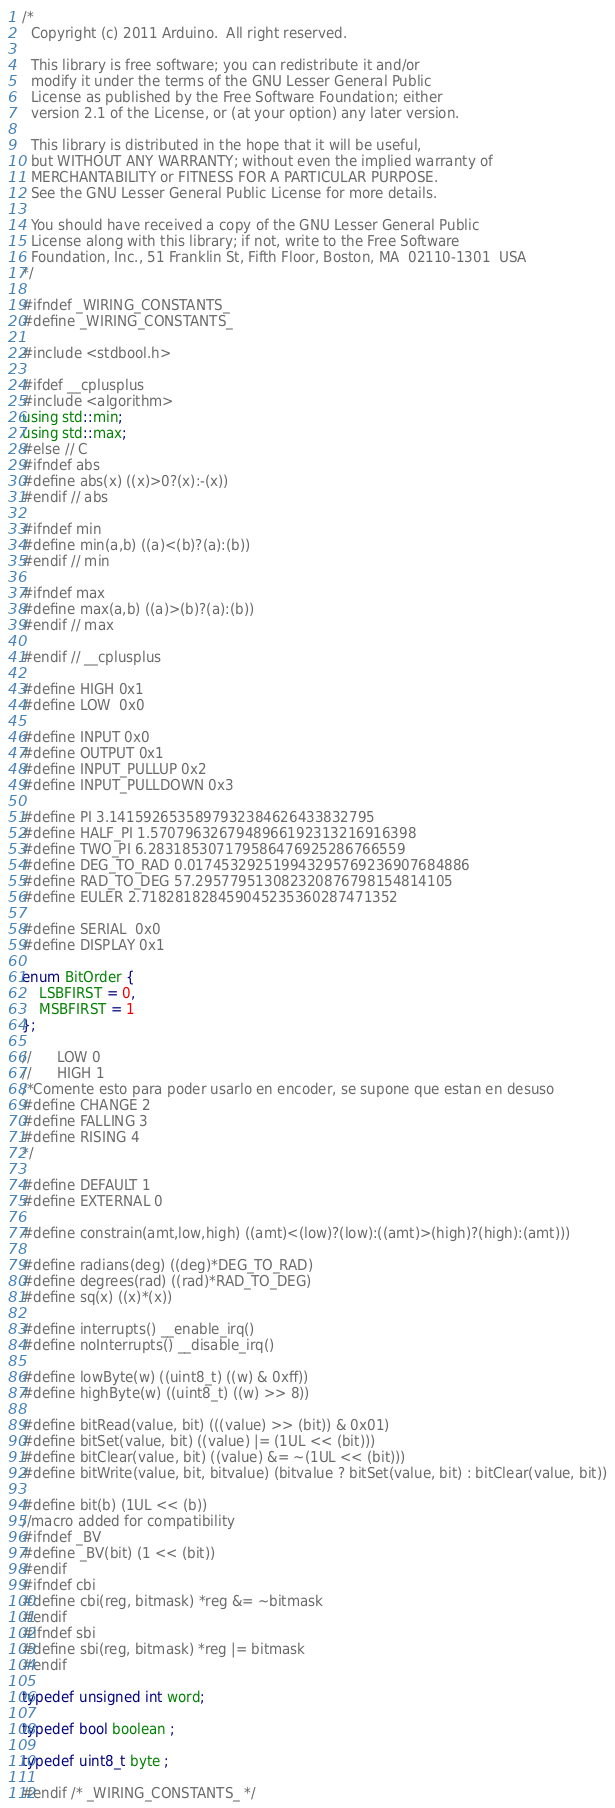<code> <loc_0><loc_0><loc_500><loc_500><_C_>/*
  Copyright (c) 2011 Arduino.  All right reserved.

  This library is free software; you can redistribute it and/or
  modify it under the terms of the GNU Lesser General Public
  License as published by the Free Software Foundation; either
  version 2.1 of the License, or (at your option) any later version.

  This library is distributed in the hope that it will be useful,
  but WITHOUT ANY WARRANTY; without even the implied warranty of
  MERCHANTABILITY or FITNESS FOR A PARTICULAR PURPOSE.
  See the GNU Lesser General Public License for more details.

  You should have received a copy of the GNU Lesser General Public
  License along with this library; if not, write to the Free Software
  Foundation, Inc., 51 Franklin St, Fifth Floor, Boston, MA  02110-1301  USA
*/

#ifndef _WIRING_CONSTANTS_
#define _WIRING_CONSTANTS_

#include <stdbool.h>

#ifdef __cplusplus
#include <algorithm>
using std::min;
using std::max;
#else // C
#ifndef abs
#define abs(x) ((x)>0?(x):-(x))
#endif // abs

#ifndef min
#define min(a,b) ((a)<(b)?(a):(b))
#endif // min

#ifndef max
#define max(a,b) ((a)>(b)?(a):(b))
#endif // max

#endif // __cplusplus

#define HIGH 0x1
#define LOW  0x0

#define INPUT 0x0
#define OUTPUT 0x1
#define INPUT_PULLUP 0x2
#define INPUT_PULLDOWN 0x3

#define PI 3.1415926535897932384626433832795
#define HALF_PI 1.5707963267948966192313216916398
#define TWO_PI 6.283185307179586476925286766559
#define DEG_TO_RAD 0.017453292519943295769236907684886
#define RAD_TO_DEG 57.295779513082320876798154814105
#define EULER 2.718281828459045235360287471352

#define SERIAL  0x0
#define DISPLAY 0x1

enum BitOrder {
	LSBFIRST = 0,
	MSBFIRST = 1
};

//      LOW 0
//      HIGH 1
/*Comente esto para poder usarlo en encoder, se supone que estan en desuso
#define CHANGE 2
#define FALLING 3
#define RISING 4
*/

#define DEFAULT 1
#define EXTERNAL 0

#define constrain(amt,low,high) ((amt)<(low)?(low):((amt)>(high)?(high):(amt)))

#define radians(deg) ((deg)*DEG_TO_RAD)
#define degrees(rad) ((rad)*RAD_TO_DEG)
#define sq(x) ((x)*(x))

#define interrupts() __enable_irq()
#define noInterrupts() __disable_irq()

#define lowByte(w) ((uint8_t) ((w) & 0xff))
#define highByte(w) ((uint8_t) ((w) >> 8))

#define bitRead(value, bit) (((value) >> (bit)) & 0x01)
#define bitSet(value, bit) ((value) |= (1UL << (bit)))
#define bitClear(value, bit) ((value) &= ~(1UL << (bit)))
#define bitWrite(value, bit, bitvalue) (bitvalue ? bitSet(value, bit) : bitClear(value, bit))

#define bit(b) (1UL << (b))
//macro added for compatibility
#ifndef _BV
#define _BV(bit) (1 << (bit))
#endif
#ifndef cbi
#define cbi(reg, bitmask) *reg &= ~bitmask
#endif
#ifndef sbi
#define sbi(reg, bitmask) *reg |= bitmask
#endif

typedef unsigned int word;

typedef bool boolean ;

typedef uint8_t byte ;

#endif /* _WIRING_CONSTANTS_ */
</code> 